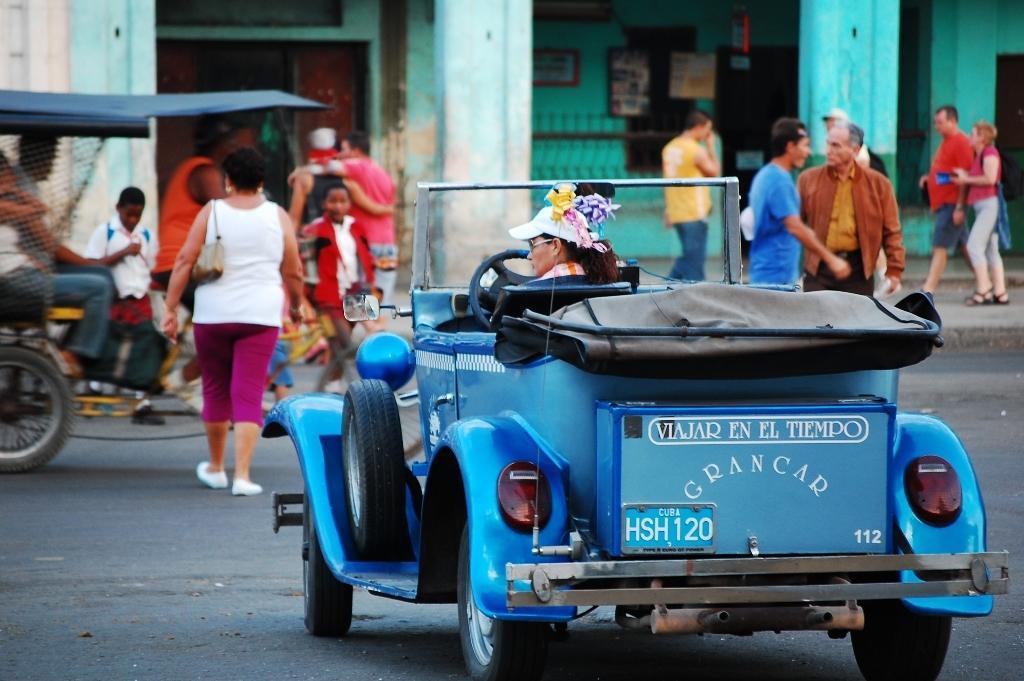Can you describe this image briefly? In this image, we can see a woman is riding a vehicle on the road. Background we can see a group of people. Few are riding vehicle and walking. Here we can see a door, pillars, walls, photo frames, some objects. 